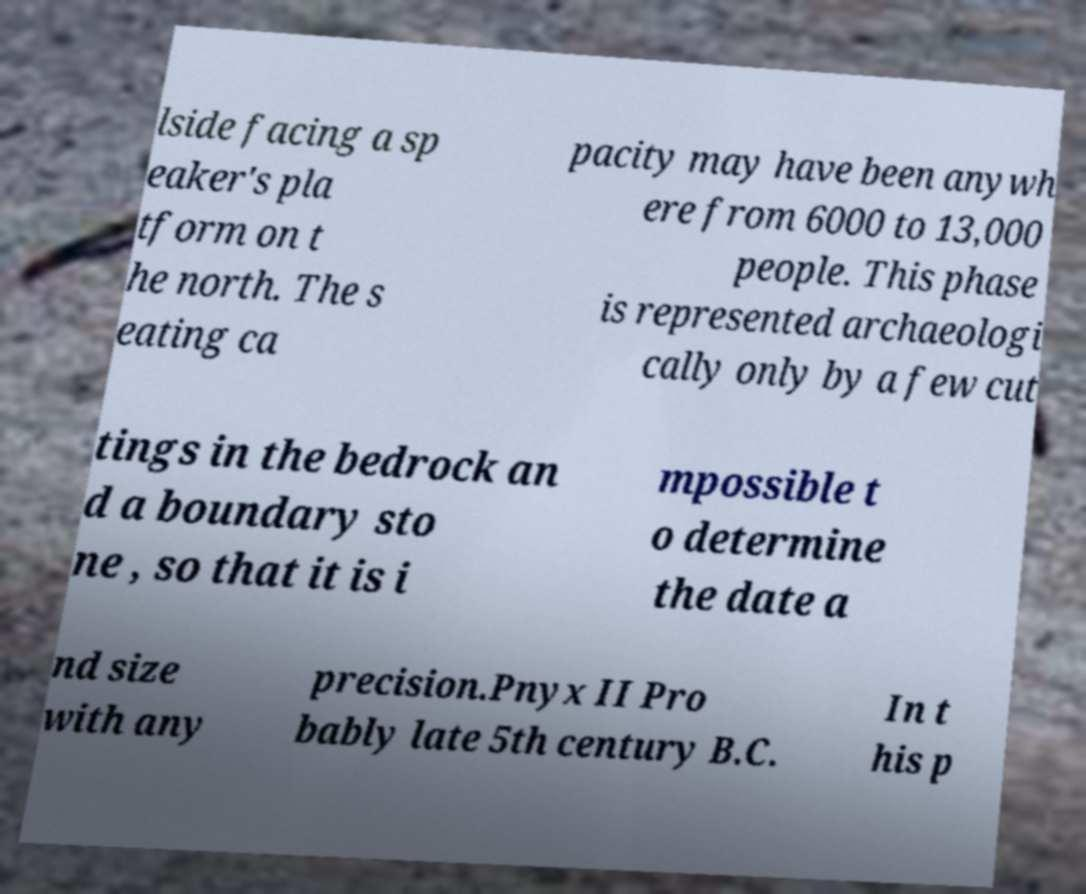What messages or text are displayed in this image? I need them in a readable, typed format. lside facing a sp eaker's pla tform on t he north. The s eating ca pacity may have been anywh ere from 6000 to 13,000 people. This phase is represented archaeologi cally only by a few cut tings in the bedrock an d a boundary sto ne , so that it is i mpossible t o determine the date a nd size with any precision.Pnyx II Pro bably late 5th century B.C. In t his p 